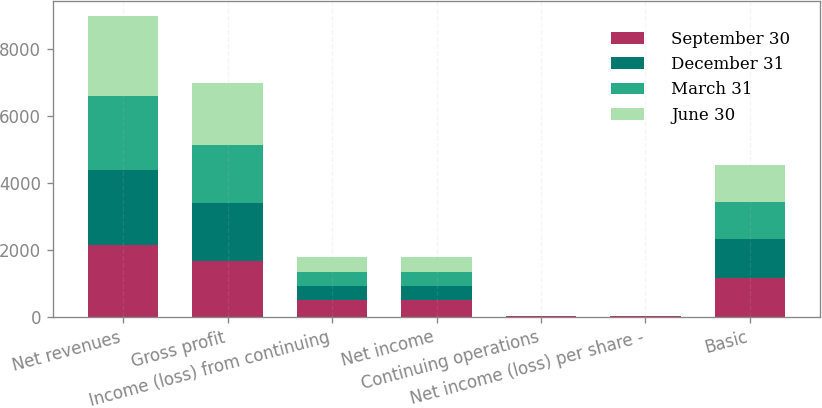Convert chart. <chart><loc_0><loc_0><loc_500><loc_500><stacked_bar_chart><ecel><fcel>Net revenues<fcel>Gross profit<fcel>Income (loss) from continuing<fcel>Net income<fcel>Continuing operations<fcel>Net income (loss) per share -<fcel>Basic<nl><fcel>September 30<fcel>2137<fcel>1660<fcel>482<fcel>482<fcel>0.42<fcel>0.41<fcel>1159<nl><fcel>December 31<fcel>2230<fcel>1737<fcel>437<fcel>435<fcel>0.38<fcel>0.38<fcel>1144<nl><fcel>March 31<fcel>2217<fcel>1719<fcel>418<fcel>413<fcel>0.37<fcel>0.36<fcel>1126<nl><fcel>June 30<fcel>2395<fcel>1856<fcel>436<fcel>436<fcel>5.38<fcel>5.3<fcel>1106<nl></chart> 